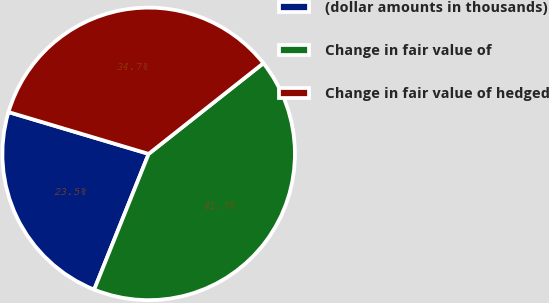Convert chart. <chart><loc_0><loc_0><loc_500><loc_500><pie_chart><fcel>(dollar amounts in thousands)<fcel>Change in fair value of<fcel>Change in fair value of hedged<nl><fcel>23.54%<fcel>41.72%<fcel>34.74%<nl></chart> 